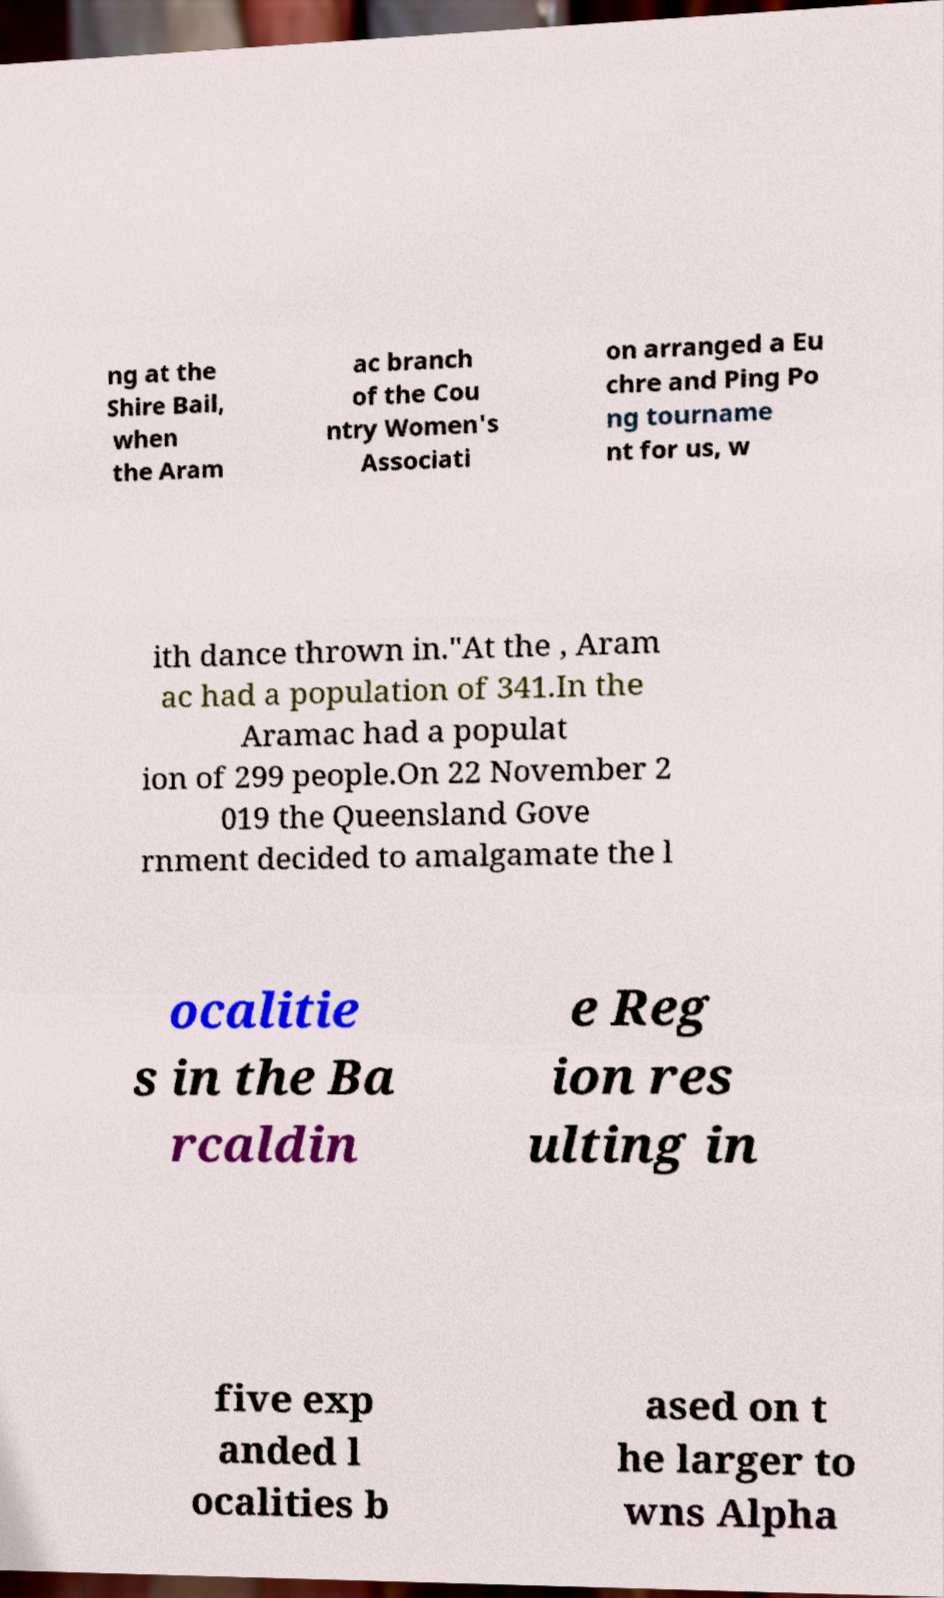Can you accurately transcribe the text from the provided image for me? ng at the Shire Bail, when the Aram ac branch of the Cou ntry Women's Associati on arranged a Eu chre and Ping Po ng tourname nt for us, w ith dance thrown in."At the , Aram ac had a population of 341.In the Aramac had a populat ion of 299 people.On 22 November 2 019 the Queensland Gove rnment decided to amalgamate the l ocalitie s in the Ba rcaldin e Reg ion res ulting in five exp anded l ocalities b ased on t he larger to wns Alpha 